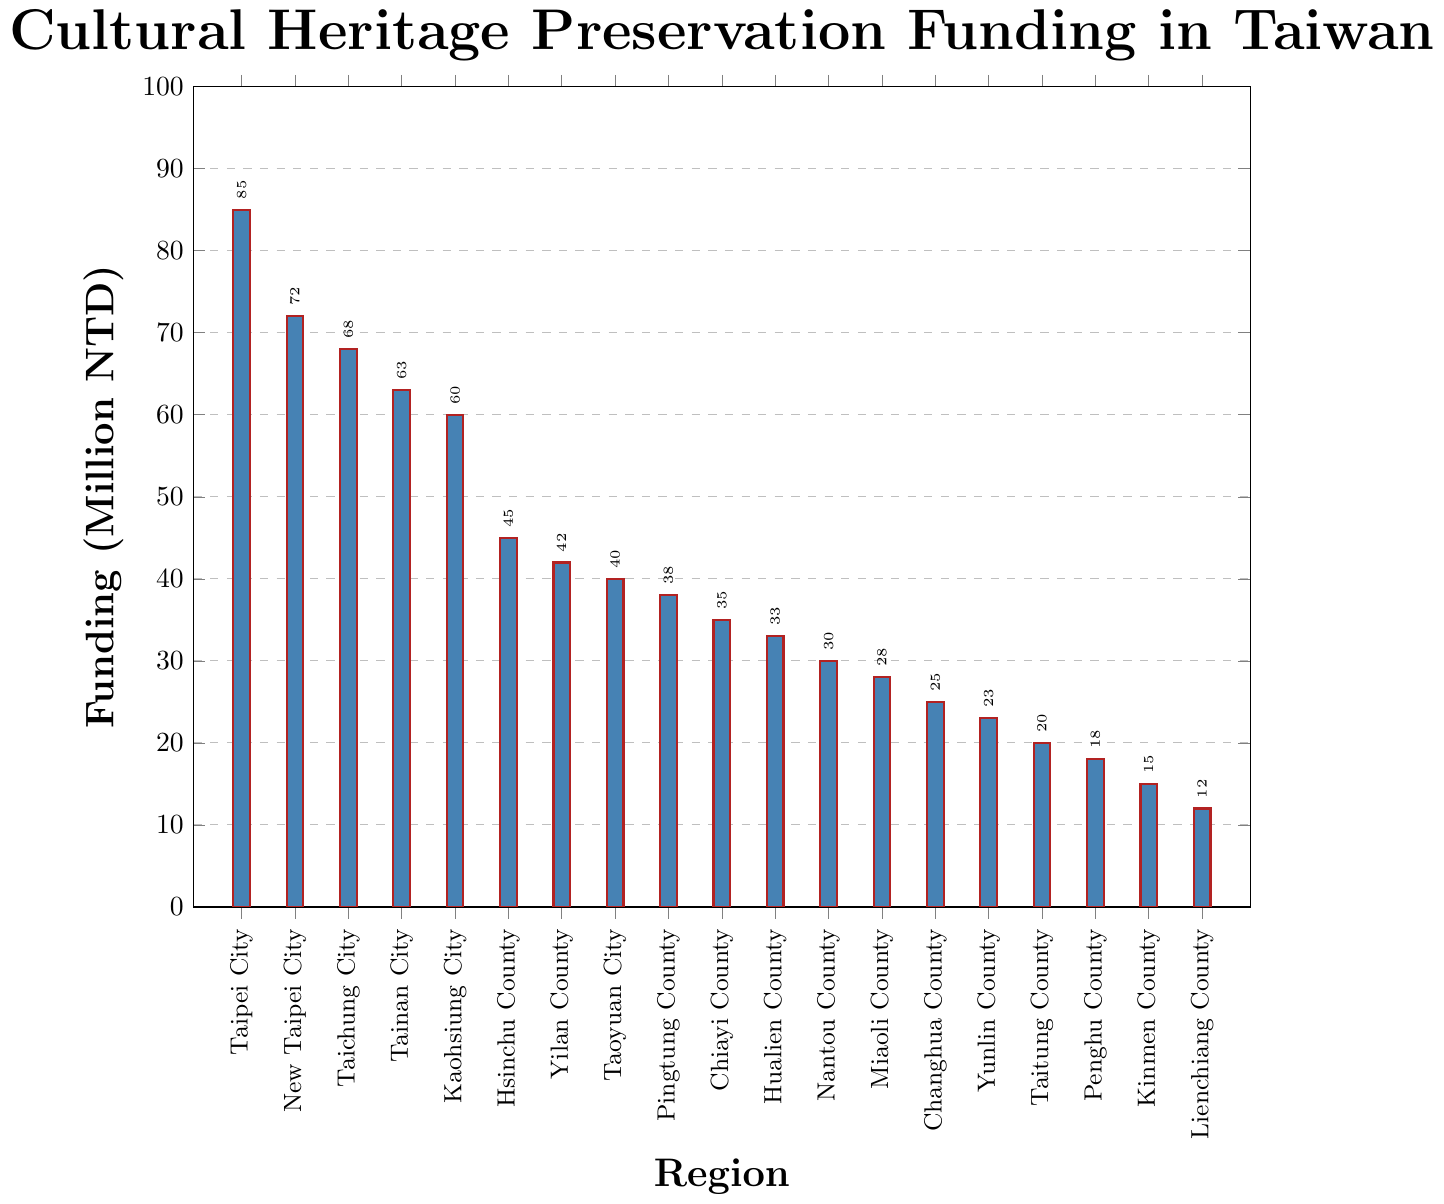What regions receive the highest and lowest funding for cultural heritage preservation? The bar representing Taipei City is the tallest, indicating the highest funding at 85 million NTD. The shortest bar is for Lienchiang County with the lowest funding at 12 million NTD.
Answer: Taipei City, Lienchiang County How much more funding does Taipei City receive compared to Kaohsiung City? Taipei City receives 85 million NTD, while Kaohsiung City receives 60 million NTD. The difference is 85 - 60 = 25 million NTD.
Answer: 25 million NTD Which regions receive funding between 60 and 70 million NTD? According to the bar heights, New Taipei City (72 million NTD), Taichung City (68 million NTD), and Tainan City (63 million NTD) fall within the 60 to 70 million NTD range.
Answer: New Taipei City, Taichung City, Tainan City What is the total funding allocated to the counties (excluding cities)? Summing up the funding for the counties: Hsinchu (45) + Yilan (42) + Pingtung (38) + Chiayi (35) + Hualien (33) + Nantou (30) + Miaoli (28) + Changhua (25) + Yunlin (23) + Taitung (20) + Penghu (18) + Kinmen (15) + Lienchiang (12) = 364 million NTD.
Answer: 364 million NTD Find the difference in funding between the regions with the second highest and second lowest funding. The second highest funding is New Taipei City with 72 million NTD. The second lowest funding is Kinmen County with 15 million NTD. The difference is 72 - 15 = 57 million NTD.
Answer: 57 million NTD Which region has funding closest to the average funding amount? First, find the average funding: (85 + 72 + 68 + 63 + 60 + 45 + 42 + 40 + 38 + 35 + 33 + 30 + 28 + 25 + 23 + 20 + 18 + 15 + 12) / 19 ≈ 40.1 million NTD. The funding closest to this average is Taoyuan City with 40 million NTD.
Answer: Taoyuan City Are there more regions with funding above or below the average funding amount? Calculate the average funding: 40.1 million NTD. Count the regions above the average (7 regions) and below it (12 regions). There are more regions below the average funding.
Answer: Below 